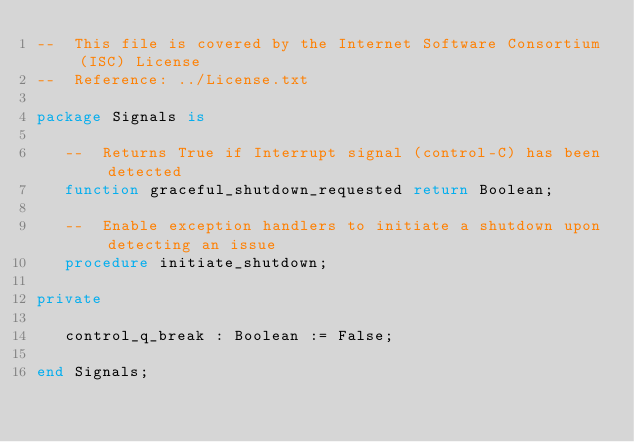<code> <loc_0><loc_0><loc_500><loc_500><_Ada_>--  This file is covered by the Internet Software Consortium (ISC) License
--  Reference: ../License.txt

package Signals is

   --  Returns True if Interrupt signal (control-C) has been detected
   function graceful_shutdown_requested return Boolean;

   --  Enable exception handlers to initiate a shutdown upon detecting an issue
   procedure initiate_shutdown;

private

   control_q_break : Boolean := False;

end Signals;
</code> 